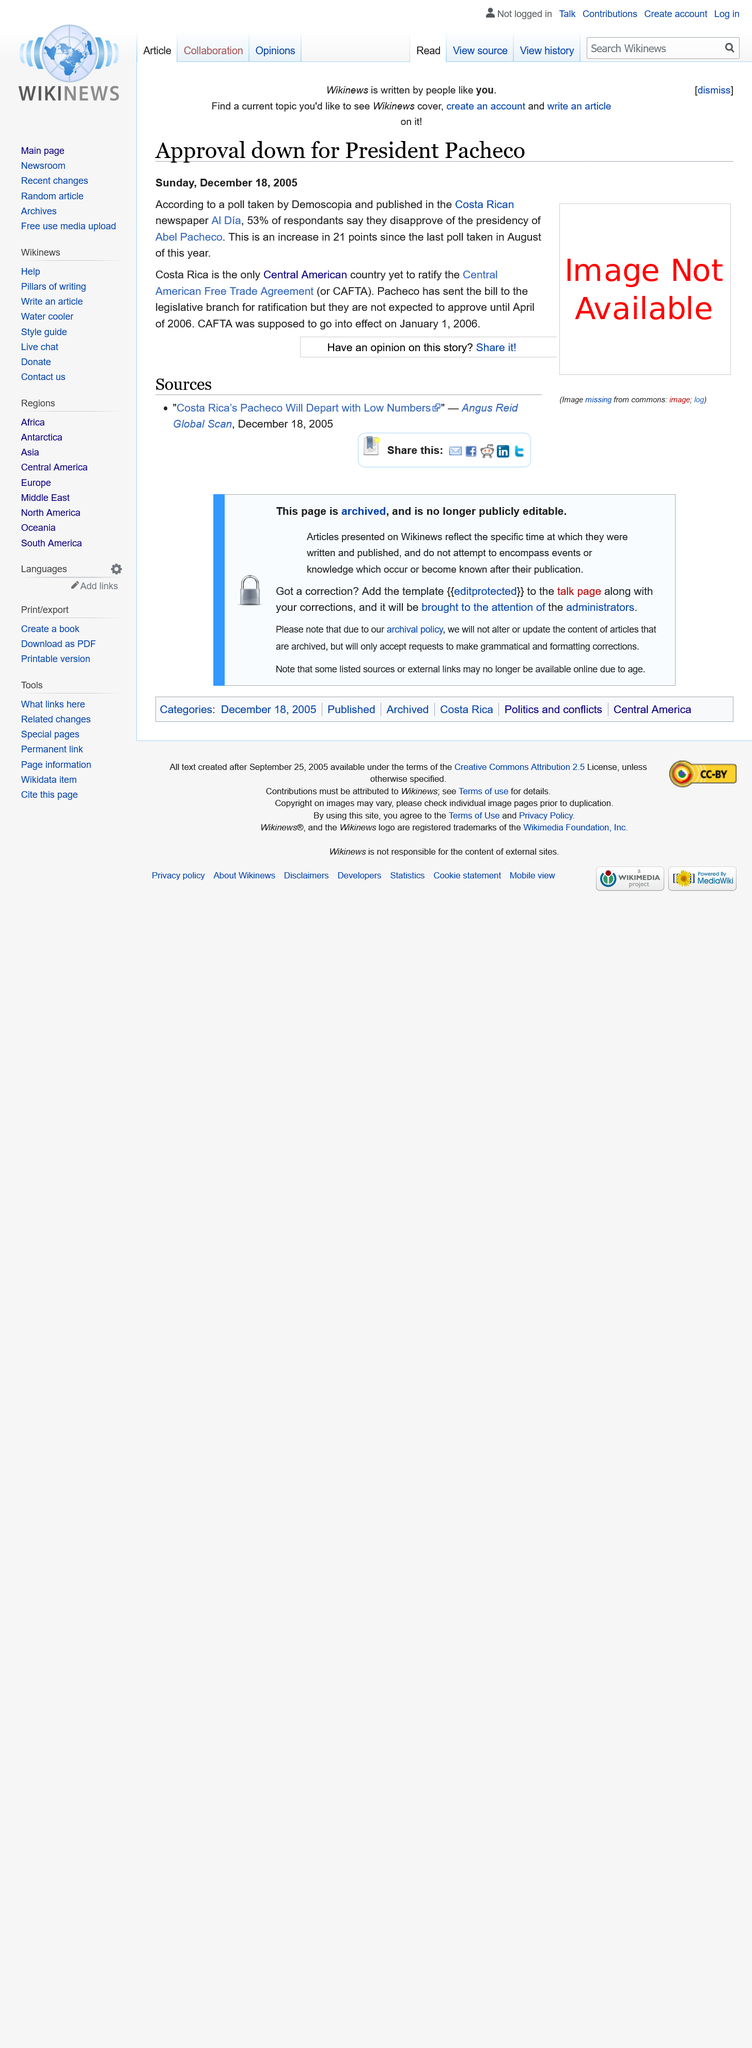Identify some key points in this picture. The approval rating for President Pacheco is down. CAFTA was scheduled to take effect on January 1, 2006, as declared. Costa Rica is the only country that has not ratified the CAFTA. 